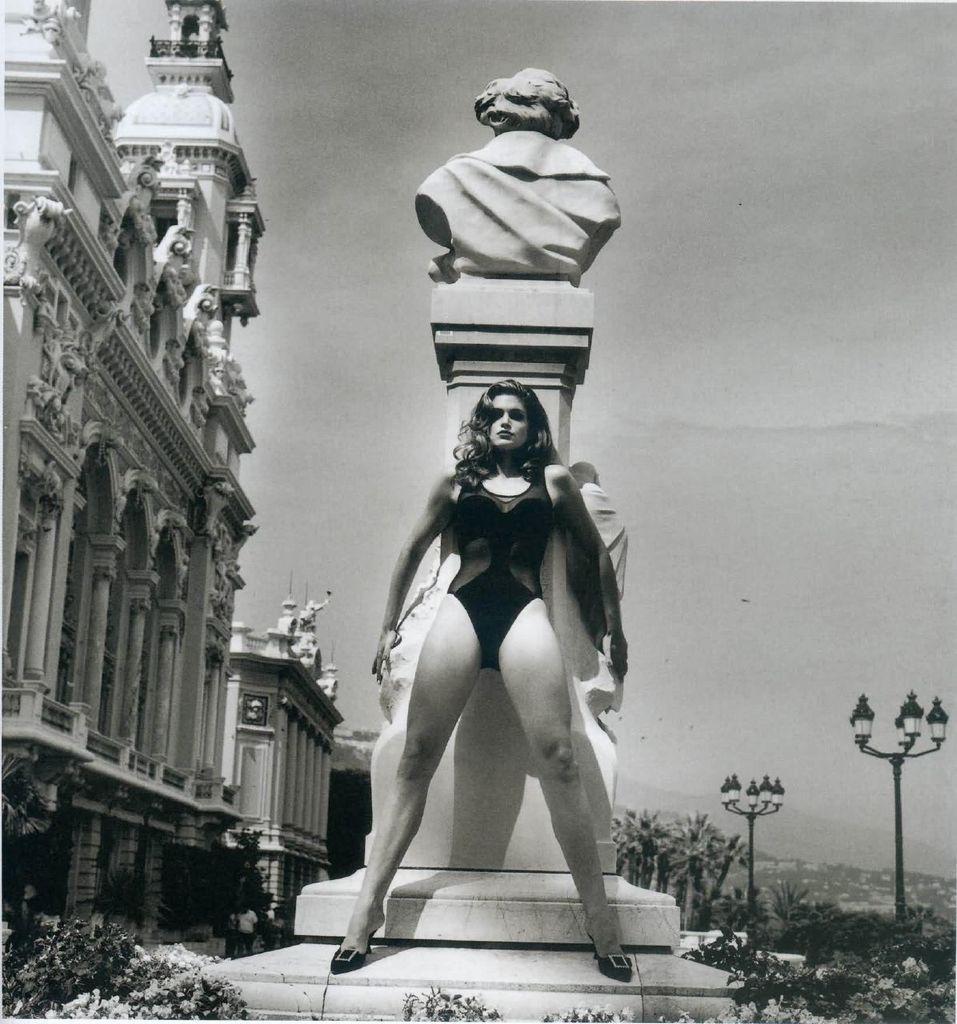Could you give a brief overview of what you see in this image? In this black and white image, we can see a person wearing clothes and standing in front of the statue. There is a building on the left side of the image. There are plants in the bottom left of the image. There are lights in the bottom right of the image. In the background of the image, there is a sky. 